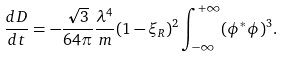<formula> <loc_0><loc_0><loc_500><loc_500>\frac { d D } { d t } = - \frac { \sqrt { 3 } } { 6 4 \pi } \frac { \lambda ^ { 4 } } { m } ( 1 - \xi _ { R } ) ^ { 2 } \int _ { - \infty } ^ { + \infty } ( \phi ^ { * } \phi ) ^ { 3 } .</formula> 